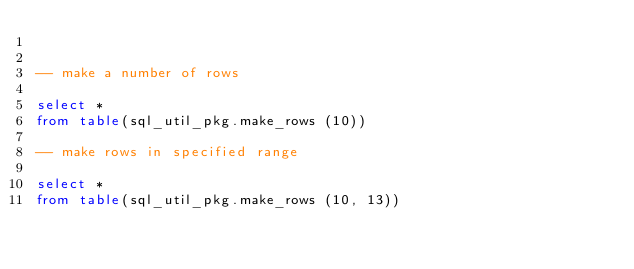<code> <loc_0><loc_0><loc_500><loc_500><_SQL_>

-- make a number of rows

select *
from table(sql_util_pkg.make_rows (10))

-- make rows in specified range

select *
from table(sql_util_pkg.make_rows (10, 13))

</code> 